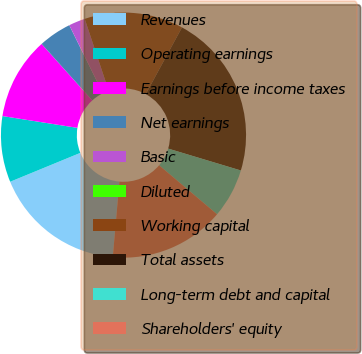<chart> <loc_0><loc_0><loc_500><loc_500><pie_chart><fcel>Revenues<fcel>Operating earnings<fcel>Earnings before income taxes<fcel>Net earnings<fcel>Basic<fcel>Diluted<fcel>Working capital<fcel>Total assets<fcel>Long-term debt and capital<fcel>Shareholders' equity<nl><fcel>17.39%<fcel>8.7%<fcel>10.87%<fcel>4.35%<fcel>2.17%<fcel>0.0%<fcel>13.04%<fcel>21.74%<fcel>6.52%<fcel>15.22%<nl></chart> 